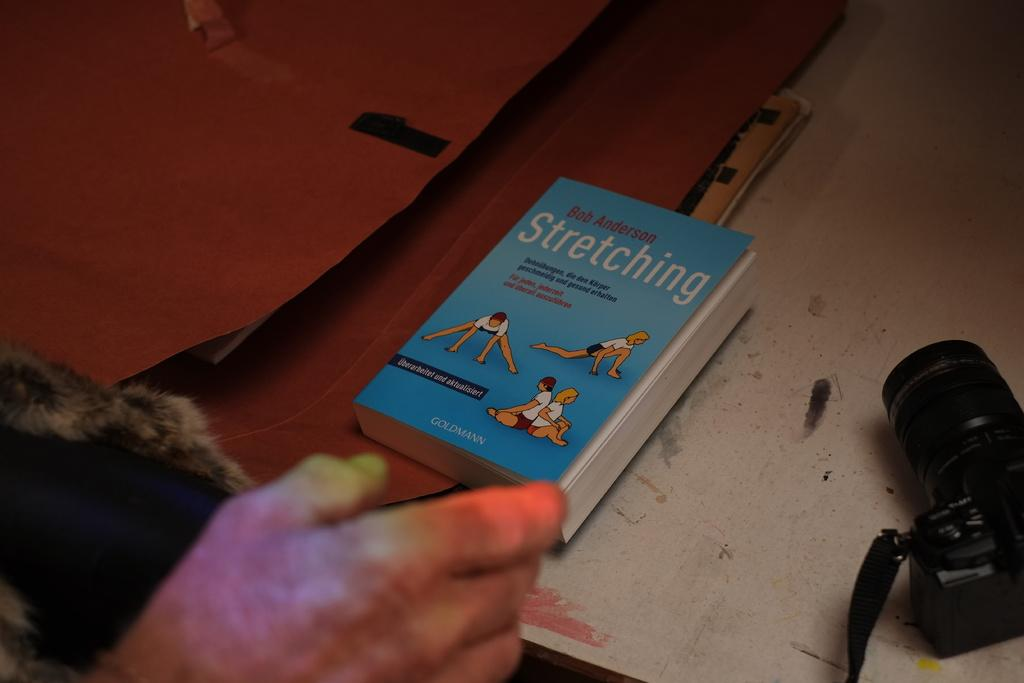<image>
Create a compact narrative representing the image presented. A small blue German language book by Bob Anderson is all about stretching. 